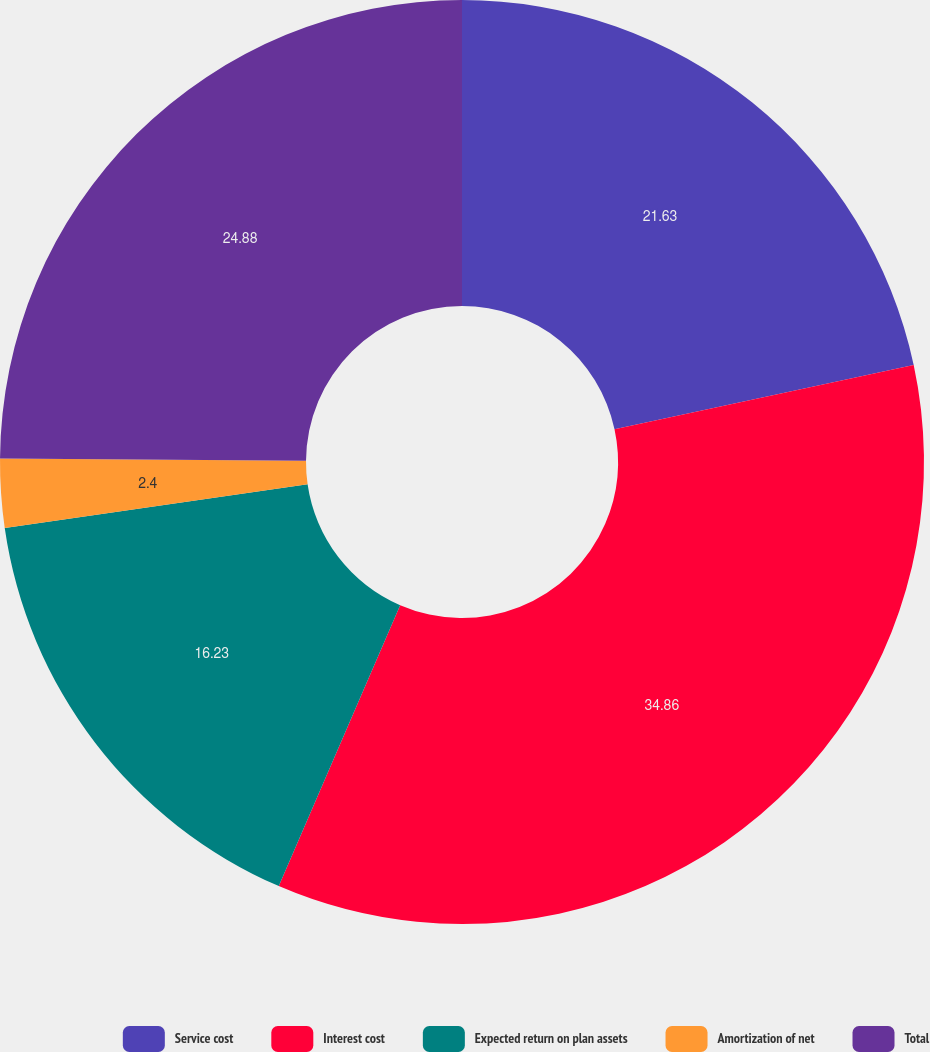<chart> <loc_0><loc_0><loc_500><loc_500><pie_chart><fcel>Service cost<fcel>Interest cost<fcel>Expected return on plan assets<fcel>Amortization of net<fcel>Total<nl><fcel>21.63%<fcel>34.86%<fcel>16.23%<fcel>2.4%<fcel>24.88%<nl></chart> 